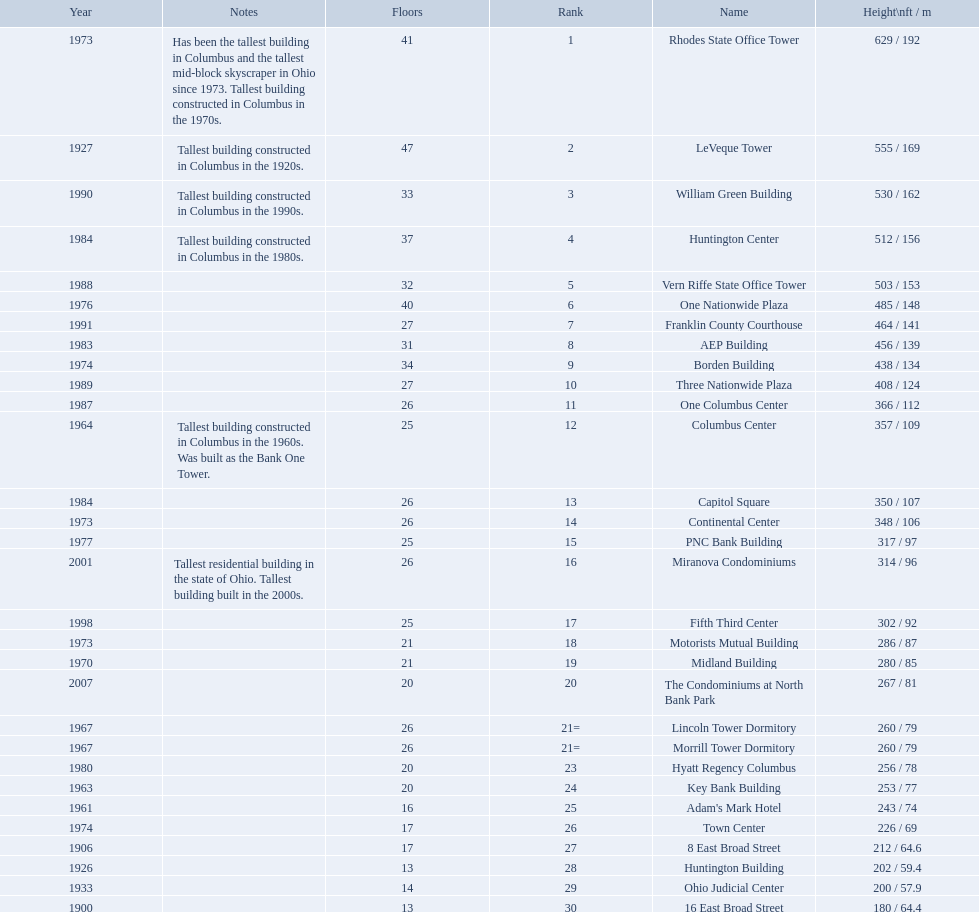How tall is the aep building? 456 / 139. How tall is the one columbus center? 366 / 112. Of these two buildings, which is taller? AEP Building. What are the heights of all the buildings 629 / 192, 555 / 169, 530 / 162, 512 / 156, 503 / 153, 485 / 148, 464 / 141, 456 / 139, 438 / 134, 408 / 124, 366 / 112, 357 / 109, 350 / 107, 348 / 106, 317 / 97, 314 / 96, 302 / 92, 286 / 87, 280 / 85, 267 / 81, 260 / 79, 260 / 79, 256 / 78, 253 / 77, 243 / 74, 226 / 69, 212 / 64.6, 202 / 59.4, 200 / 57.9, 180 / 64.4. What are the heights of the aep and columbus center buildings 456 / 139, 357 / 109. Which height is greater? 456 / 139. What building is this for? AEP Building. 